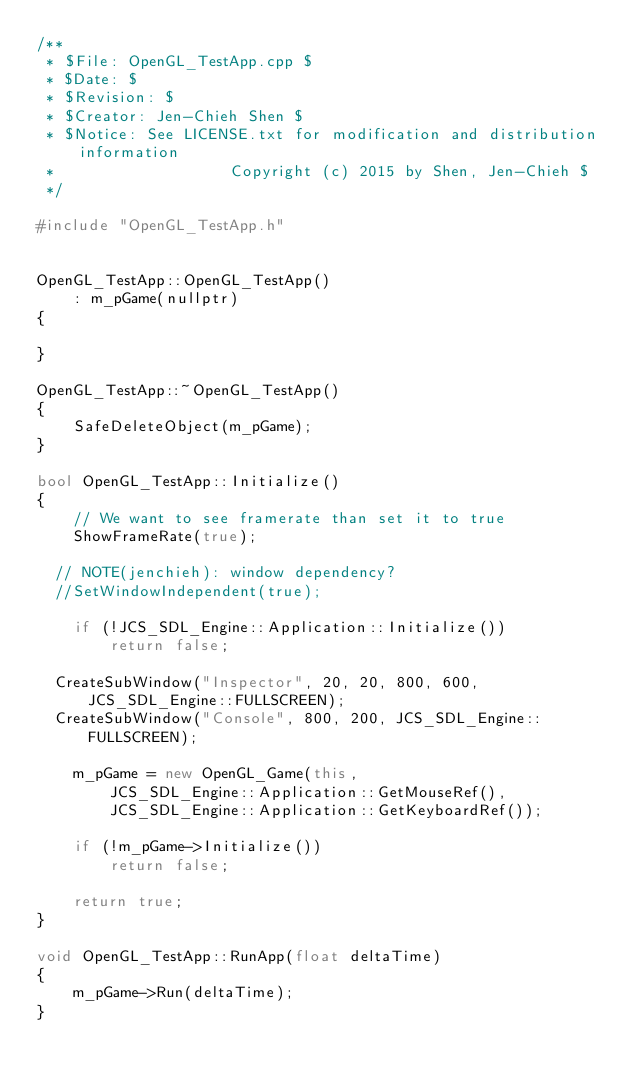<code> <loc_0><loc_0><loc_500><loc_500><_C++_>/**
 * $File: OpenGL_TestApp.cpp $
 * $Date: $
 * $Revision: $
 * $Creator: Jen-Chieh Shen $
 * $Notice: See LICENSE.txt for modification and distribution information
 *                   Copyright (c) 2015 by Shen, Jen-Chieh $
 */

#include "OpenGL_TestApp.h"


OpenGL_TestApp::OpenGL_TestApp()
    : m_pGame(nullptr)
{

}

OpenGL_TestApp::~OpenGL_TestApp()
{
    SafeDeleteObject(m_pGame);
}

bool OpenGL_TestApp::Initialize()
{
    // We want to see framerate than set it to true
    ShowFrameRate(true);

	// NOTE(jenchieh): window dependency?
	//SetWindowIndependent(true);

    if (!JCS_SDL_Engine::Application::Initialize())
        return false;

	CreateSubWindow("Inspector", 20, 20, 800, 600, JCS_SDL_Engine::FULLSCREEN);
	CreateSubWindow("Console", 800, 200, JCS_SDL_Engine::FULLSCREEN);

    m_pGame = new OpenGL_Game(this, 
        JCS_SDL_Engine::Application::GetMouseRef(), 
        JCS_SDL_Engine::Application::GetKeyboardRef());

    if (!m_pGame->Initialize())
        return false;

    return true;
}

void OpenGL_TestApp::RunApp(float deltaTime)
{
    m_pGame->Run(deltaTime);
}


</code> 